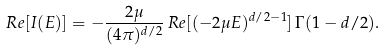<formula> <loc_0><loc_0><loc_500><loc_500>R e [ I ( E ) ] = - \frac { 2 \mu } { ( 4 \pi ) ^ { d / 2 } } \, R e [ ( - 2 \mu E ) ^ { d / 2 - 1 } ] \, \Gamma ( 1 - d / 2 ) .</formula> 